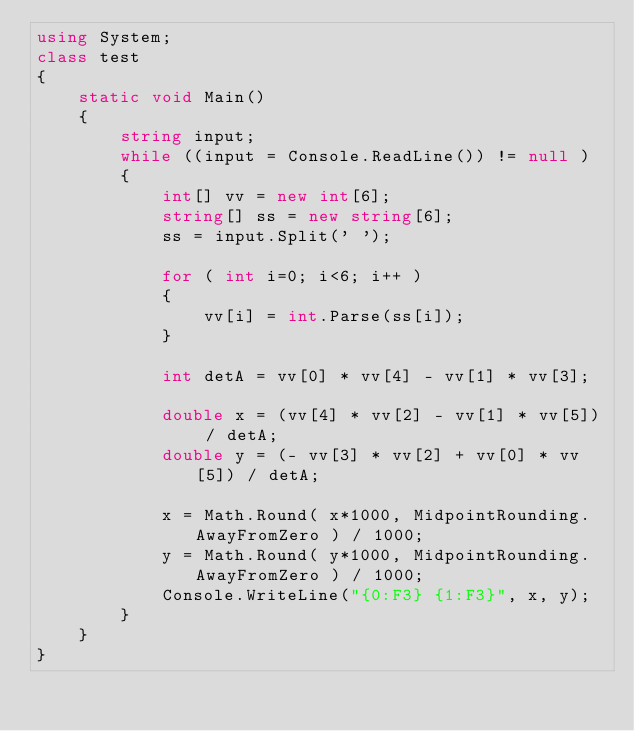Convert code to text. <code><loc_0><loc_0><loc_500><loc_500><_C#_>using System;
class test
{
	static void Main()
	{
		string input;
		while ((input = Console.ReadLine()) != null )
		{
			int[] vv = new int[6];
			string[] ss = new string[6];
			ss = input.Split(' ');

			for ( int i=0; i<6; i++ )
			{
				vv[i] = int.Parse(ss[i]);
			}

			int detA = vv[0] * vv[4] - vv[1] * vv[3];

			double x = (vv[4] * vv[2] - vv[1] * vv[5]) / detA;
			double y = (- vv[3] * vv[2] + vv[0] * vv[5]) / detA;
			
			x = Math.Round( x*1000, MidpointRounding.AwayFromZero ) / 1000;
			y = Math.Round( y*1000, MidpointRounding.AwayFromZero ) / 1000;
			Console.WriteLine("{0:F3} {1:F3}", x, y);
		}
	}
}</code> 